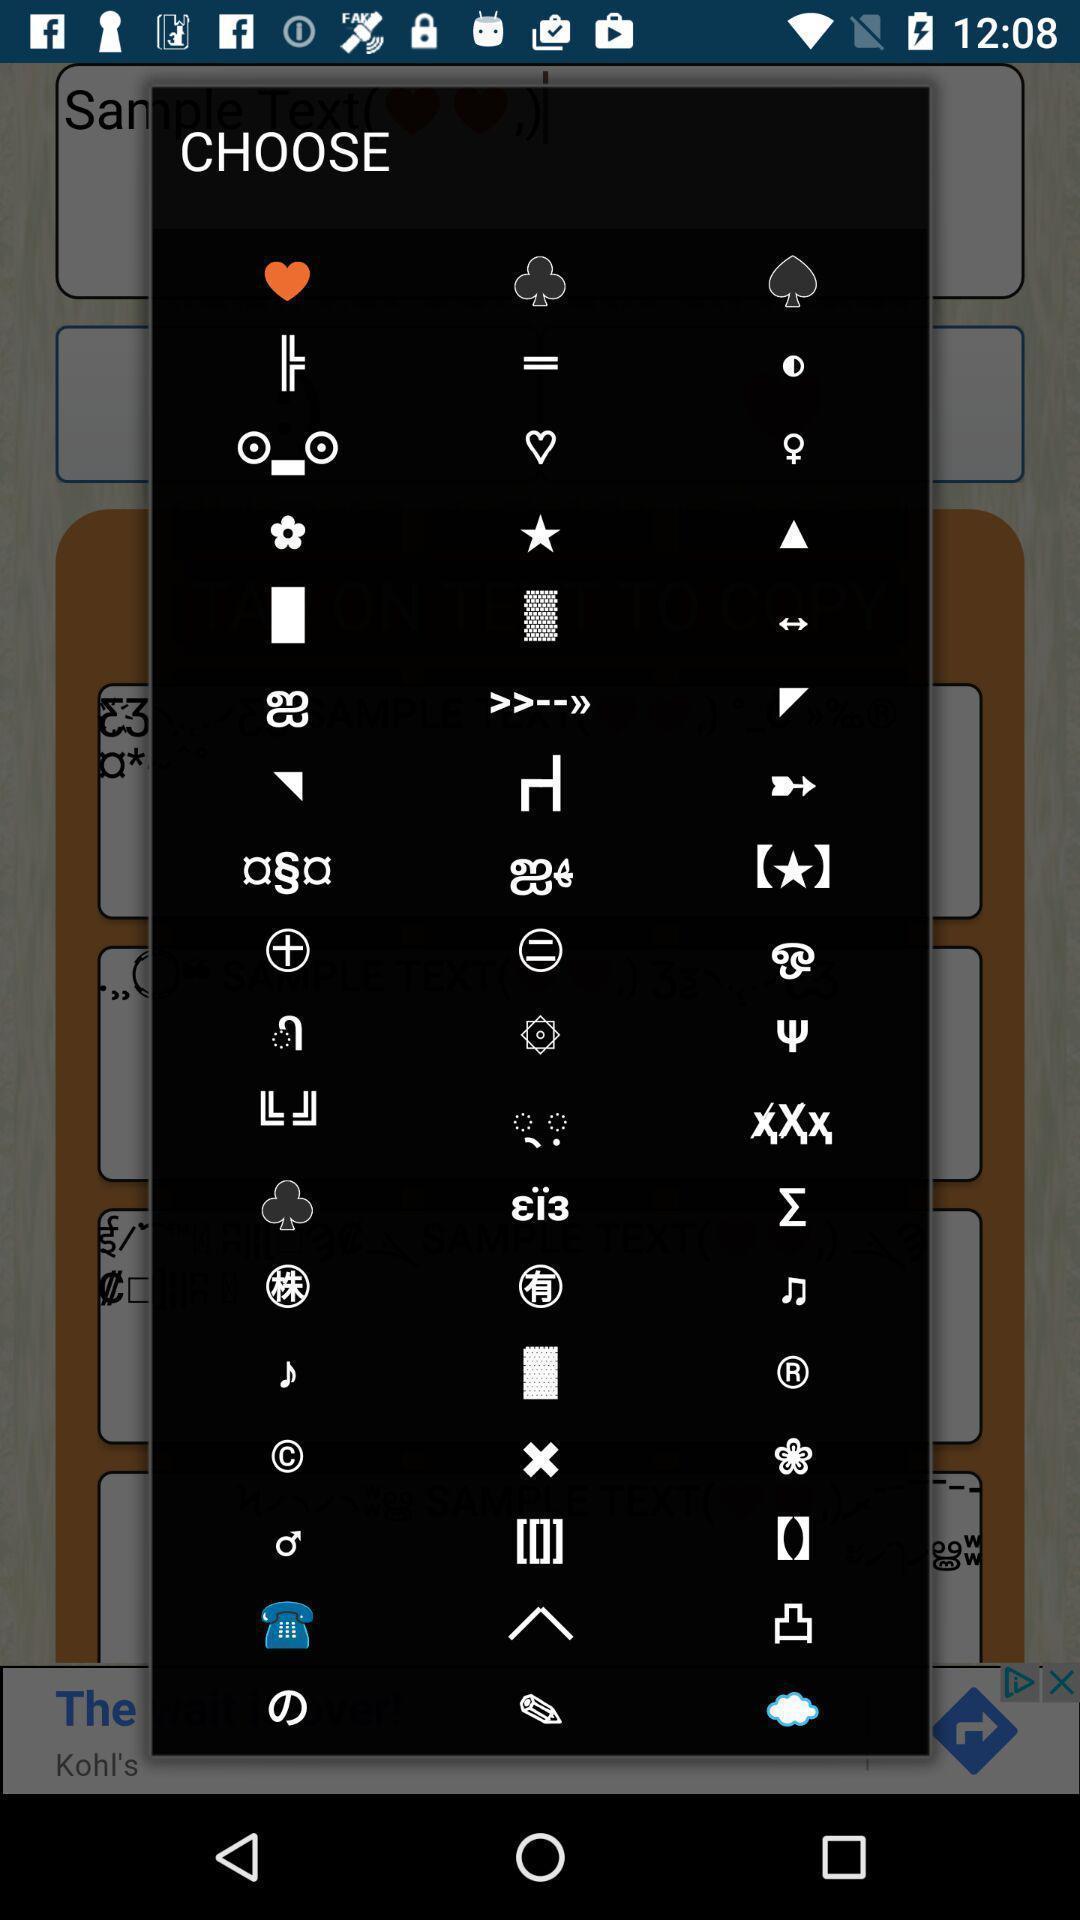Provide a textual representation of this image. Popup displaying to choose a symbol from the list. 